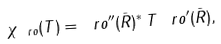<formula> <loc_0><loc_0><loc_500><loc_500>\chi _ { \ r o } ( T ) = \ r o ^ { \prime \prime } ( \bar { R } ) ^ { * } \, T \, \ r o ^ { \prime } ( \bar { R } ) ,</formula> 